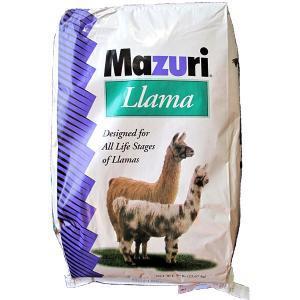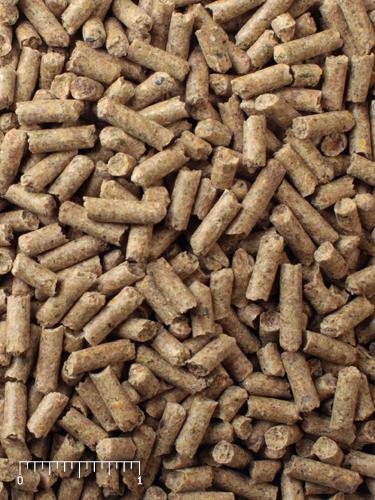The first image is the image on the left, the second image is the image on the right. Given the left and right images, does the statement "The left image contains one bag of food with two hooved animals on the front of the package, and the right image contains a mass of small bits of animal feed." hold true? Answer yes or no. Yes. The first image is the image on the left, the second image is the image on the right. Analyze the images presented: Is the assertion "One image shows loose pet food pellets and another image shows a bag of animal food." valid? Answer yes or no. Yes. 